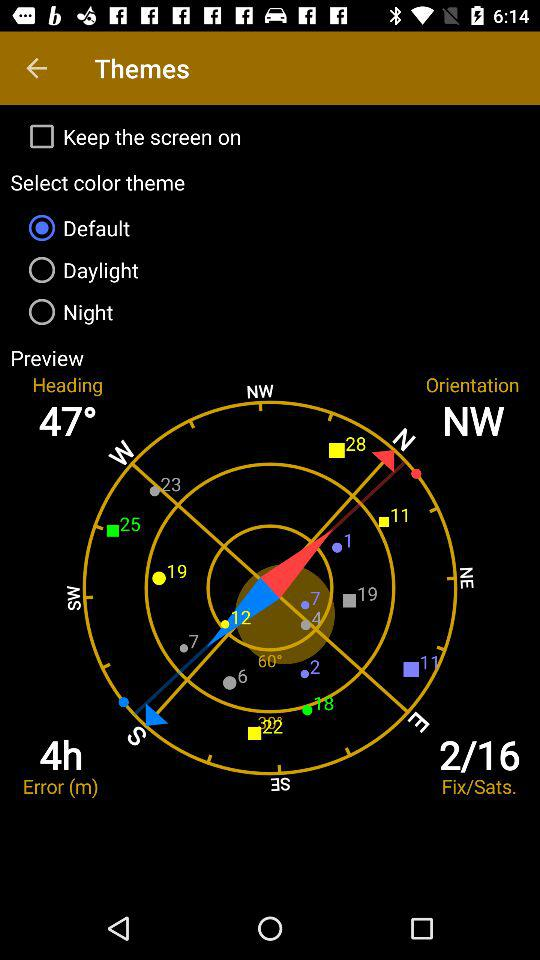What is the heading direction? The heading direction is 47°. 